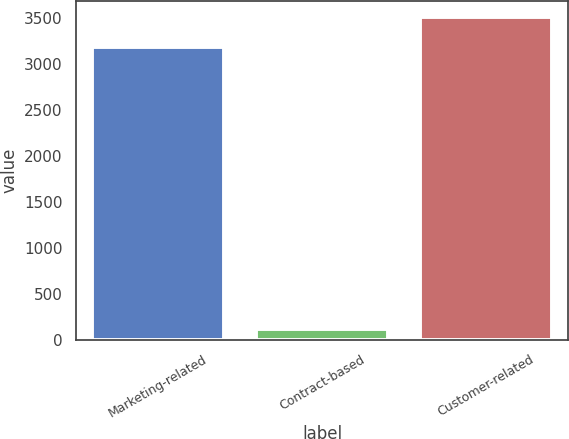Convert chart. <chart><loc_0><loc_0><loc_500><loc_500><bar_chart><fcel>Marketing-related<fcel>Contract-based<fcel>Customer-related<nl><fcel>3187<fcel>119<fcel>3510.4<nl></chart> 